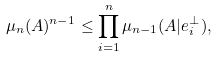Convert formula to latex. <formula><loc_0><loc_0><loc_500><loc_500>\mu _ { n } ( A ) ^ { n - 1 } \leq \prod _ { i = 1 } ^ { n } \mu _ { n - 1 } ( A | e _ { i } ^ { \perp } ) ,</formula> 